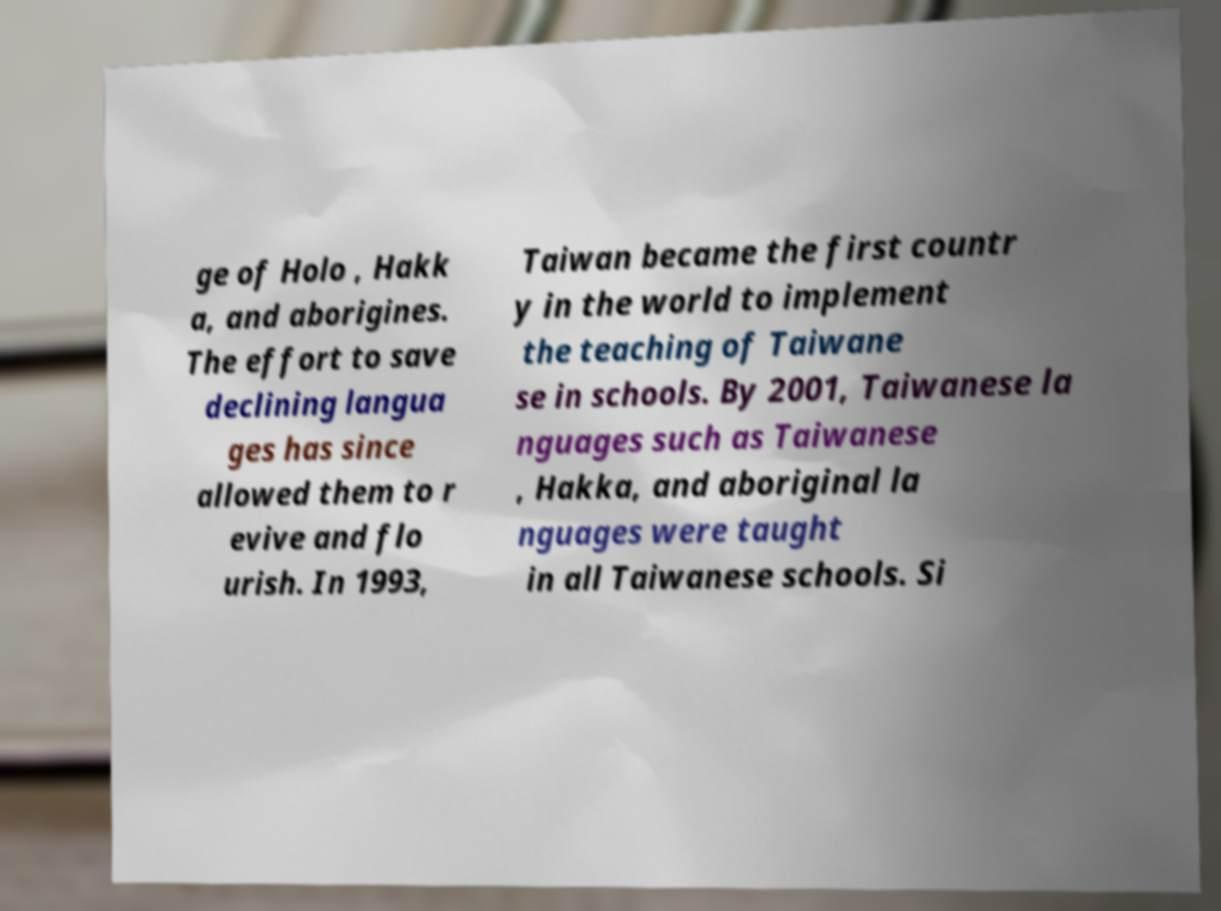I need the written content from this picture converted into text. Can you do that? ge of Holo , Hakk a, and aborigines. The effort to save declining langua ges has since allowed them to r evive and flo urish. In 1993, Taiwan became the first countr y in the world to implement the teaching of Taiwane se in schools. By 2001, Taiwanese la nguages such as Taiwanese , Hakka, and aboriginal la nguages were taught in all Taiwanese schools. Si 